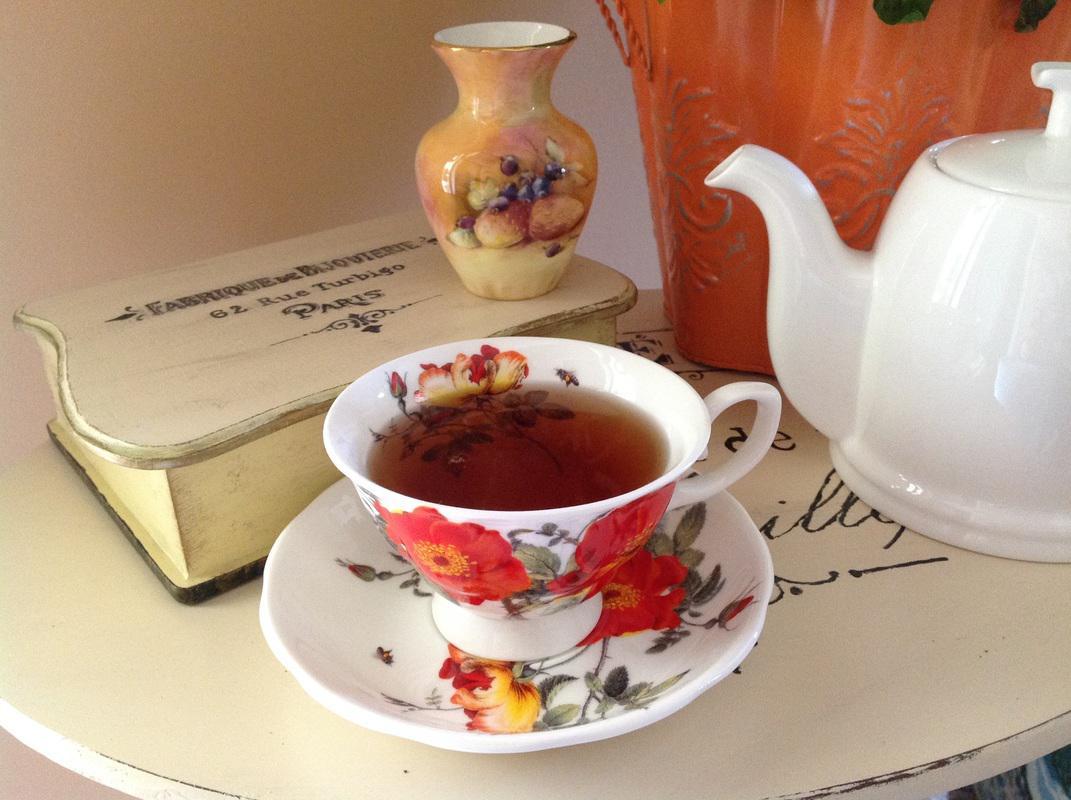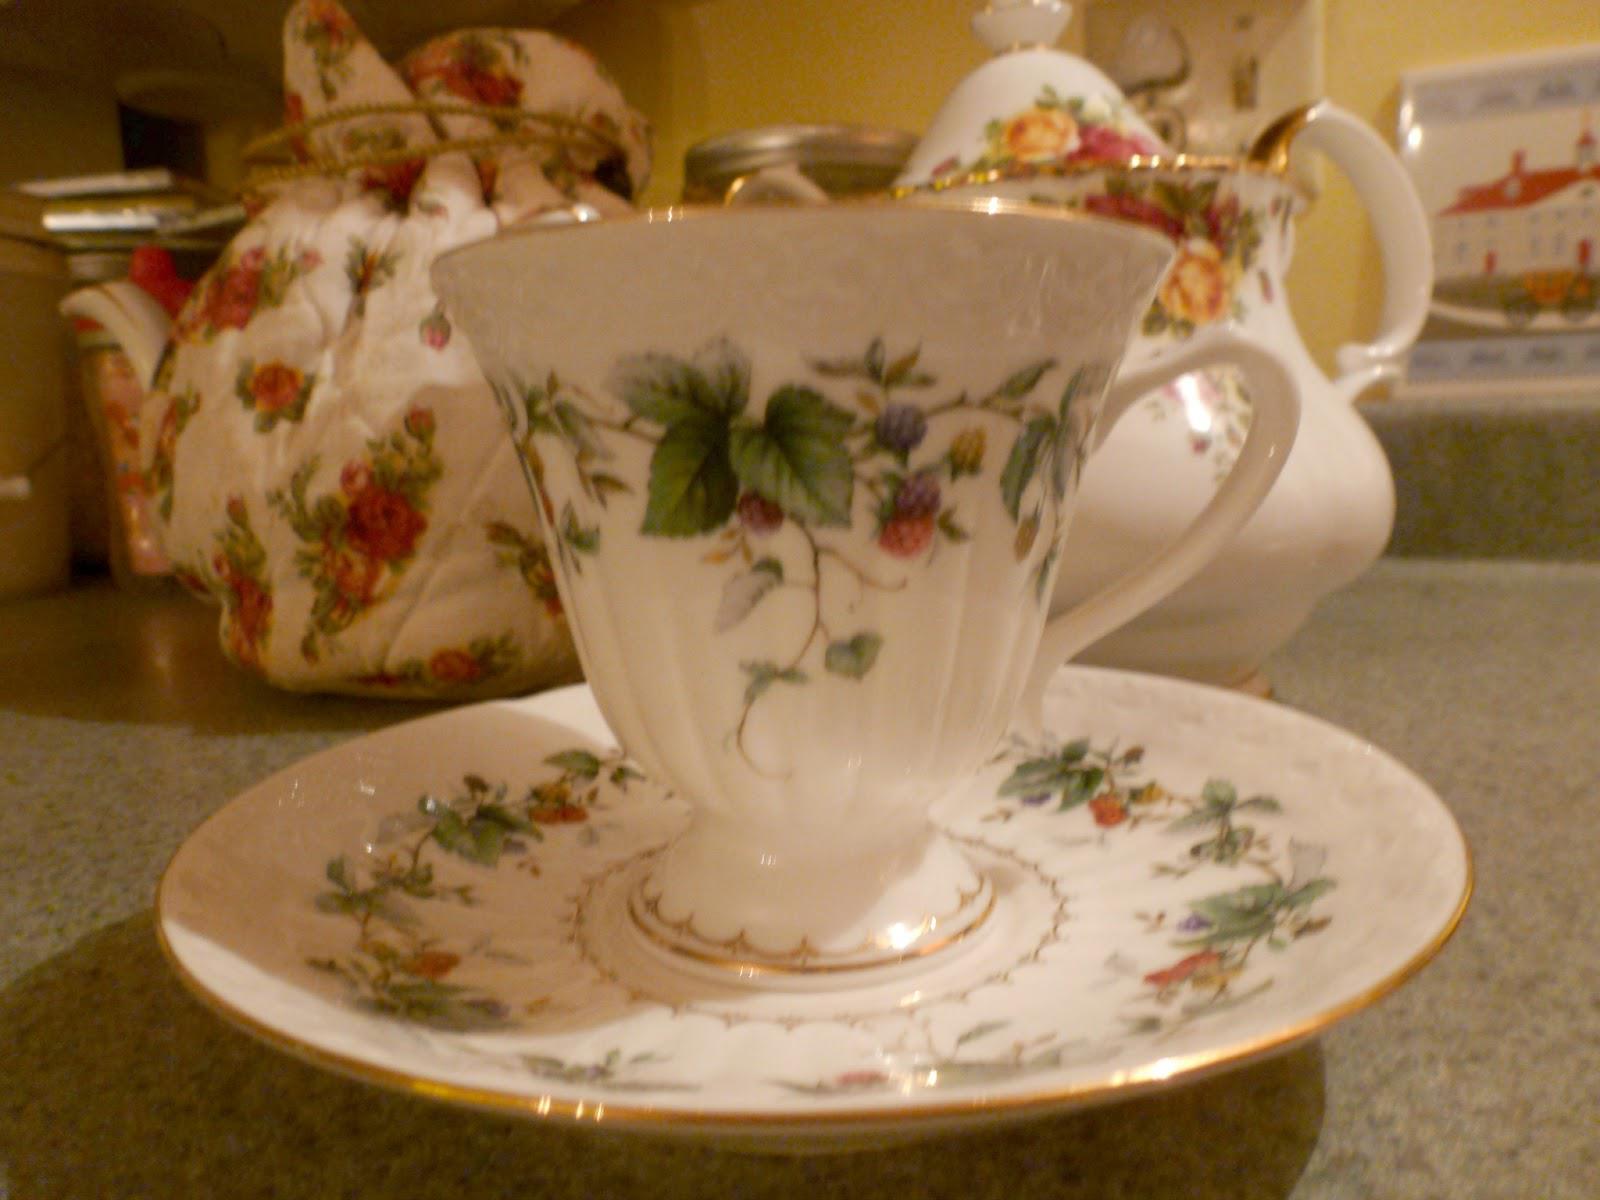The first image is the image on the left, the second image is the image on the right. Analyze the images presented: Is the assertion "No more than one tea pot is visible." valid? Answer yes or no. No. The first image is the image on the left, the second image is the image on the right. For the images displayed, is the sentence "One of the teacups is blue with pink flowers on it." factually correct? Answer yes or no. No. 